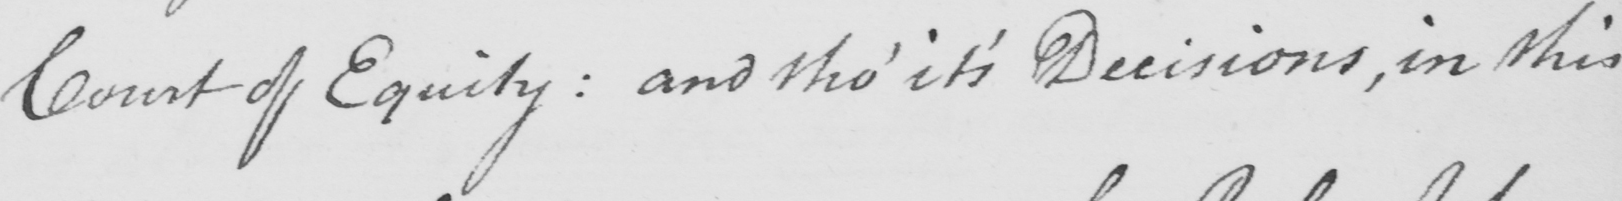Please transcribe the handwritten text in this image. Court of Equity :  and tho '  it ' s Decisions , in this 